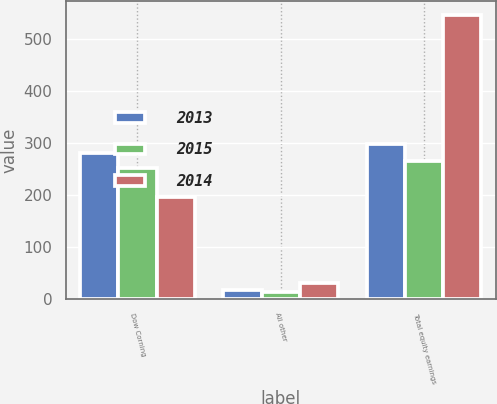<chart> <loc_0><loc_0><loc_500><loc_500><stacked_bar_chart><ecel><fcel>Dow Corning<fcel>All other<fcel>Total equity earnings<nl><fcel>2013<fcel>281<fcel>18<fcel>299<nl><fcel>2015<fcel>252<fcel>14<fcel>266<nl><fcel>2014<fcel>196<fcel>31<fcel>547<nl></chart> 